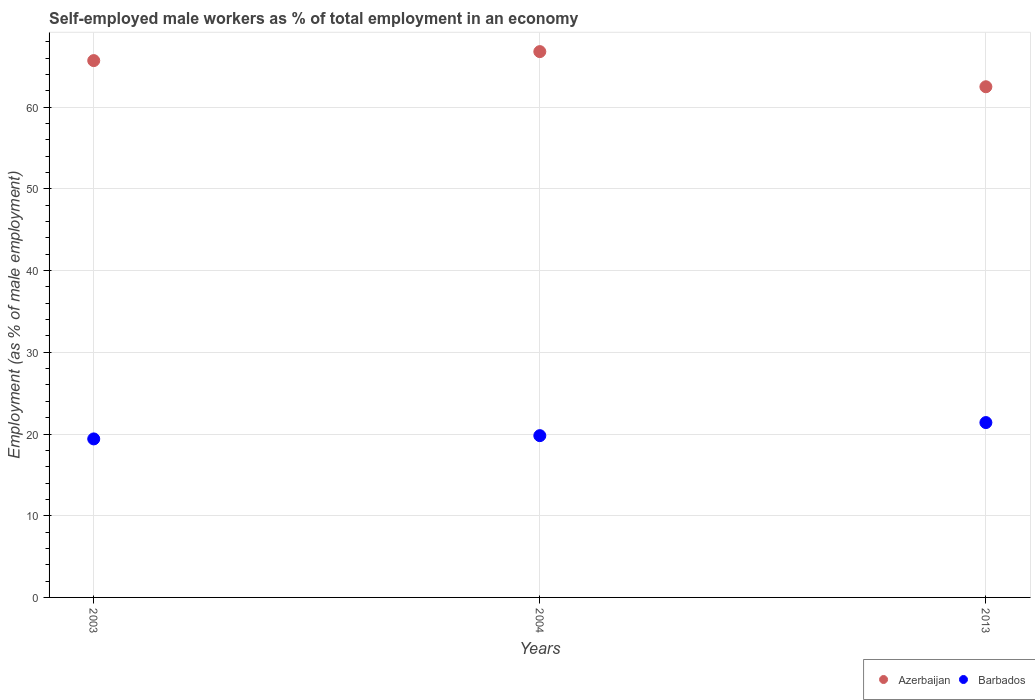Is the number of dotlines equal to the number of legend labels?
Your response must be concise. Yes. What is the percentage of self-employed male workers in Barbados in 2003?
Make the answer very short. 19.4. Across all years, what is the maximum percentage of self-employed male workers in Barbados?
Offer a terse response. 21.4. Across all years, what is the minimum percentage of self-employed male workers in Barbados?
Your answer should be very brief. 19.4. What is the total percentage of self-employed male workers in Azerbaijan in the graph?
Offer a terse response. 195. What is the difference between the percentage of self-employed male workers in Azerbaijan in 2004 and that in 2013?
Make the answer very short. 4.3. What is the difference between the percentage of self-employed male workers in Barbados in 2004 and the percentage of self-employed male workers in Azerbaijan in 2013?
Ensure brevity in your answer.  -42.7. What is the average percentage of self-employed male workers in Barbados per year?
Give a very brief answer. 20.2. In the year 2013, what is the difference between the percentage of self-employed male workers in Azerbaijan and percentage of self-employed male workers in Barbados?
Provide a succinct answer. 41.1. In how many years, is the percentage of self-employed male workers in Barbados greater than 58 %?
Make the answer very short. 0. What is the ratio of the percentage of self-employed male workers in Barbados in 2003 to that in 2013?
Your answer should be very brief. 0.91. Is the difference between the percentage of self-employed male workers in Azerbaijan in 2004 and 2013 greater than the difference between the percentage of self-employed male workers in Barbados in 2004 and 2013?
Provide a short and direct response. Yes. What is the difference between the highest and the second highest percentage of self-employed male workers in Barbados?
Offer a terse response. 1.6. What is the difference between the highest and the lowest percentage of self-employed male workers in Azerbaijan?
Make the answer very short. 4.3. Is the sum of the percentage of self-employed male workers in Azerbaijan in 2004 and 2013 greater than the maximum percentage of self-employed male workers in Barbados across all years?
Provide a succinct answer. Yes. How many years are there in the graph?
Offer a very short reply. 3. Does the graph contain any zero values?
Give a very brief answer. No. Does the graph contain grids?
Provide a short and direct response. Yes. Where does the legend appear in the graph?
Ensure brevity in your answer.  Bottom right. How many legend labels are there?
Ensure brevity in your answer.  2. What is the title of the graph?
Ensure brevity in your answer.  Self-employed male workers as % of total employment in an economy. Does "Low & middle income" appear as one of the legend labels in the graph?
Your answer should be very brief. No. What is the label or title of the X-axis?
Ensure brevity in your answer.  Years. What is the label or title of the Y-axis?
Give a very brief answer. Employment (as % of male employment). What is the Employment (as % of male employment) of Azerbaijan in 2003?
Keep it short and to the point. 65.7. What is the Employment (as % of male employment) in Barbados in 2003?
Offer a terse response. 19.4. What is the Employment (as % of male employment) of Azerbaijan in 2004?
Give a very brief answer. 66.8. What is the Employment (as % of male employment) in Barbados in 2004?
Provide a succinct answer. 19.8. What is the Employment (as % of male employment) of Azerbaijan in 2013?
Your response must be concise. 62.5. What is the Employment (as % of male employment) of Barbados in 2013?
Offer a terse response. 21.4. Across all years, what is the maximum Employment (as % of male employment) in Azerbaijan?
Ensure brevity in your answer.  66.8. Across all years, what is the maximum Employment (as % of male employment) in Barbados?
Your answer should be very brief. 21.4. Across all years, what is the minimum Employment (as % of male employment) in Azerbaijan?
Your answer should be compact. 62.5. Across all years, what is the minimum Employment (as % of male employment) of Barbados?
Provide a succinct answer. 19.4. What is the total Employment (as % of male employment) in Azerbaijan in the graph?
Offer a very short reply. 195. What is the total Employment (as % of male employment) in Barbados in the graph?
Give a very brief answer. 60.6. What is the difference between the Employment (as % of male employment) of Azerbaijan in 2004 and that in 2013?
Keep it short and to the point. 4.3. What is the difference between the Employment (as % of male employment) in Azerbaijan in 2003 and the Employment (as % of male employment) in Barbados in 2004?
Your answer should be very brief. 45.9. What is the difference between the Employment (as % of male employment) of Azerbaijan in 2003 and the Employment (as % of male employment) of Barbados in 2013?
Keep it short and to the point. 44.3. What is the difference between the Employment (as % of male employment) of Azerbaijan in 2004 and the Employment (as % of male employment) of Barbados in 2013?
Make the answer very short. 45.4. What is the average Employment (as % of male employment) in Barbados per year?
Make the answer very short. 20.2. In the year 2003, what is the difference between the Employment (as % of male employment) in Azerbaijan and Employment (as % of male employment) in Barbados?
Keep it short and to the point. 46.3. In the year 2013, what is the difference between the Employment (as % of male employment) in Azerbaijan and Employment (as % of male employment) in Barbados?
Provide a short and direct response. 41.1. What is the ratio of the Employment (as % of male employment) in Azerbaijan in 2003 to that in 2004?
Provide a succinct answer. 0.98. What is the ratio of the Employment (as % of male employment) in Barbados in 2003 to that in 2004?
Your answer should be compact. 0.98. What is the ratio of the Employment (as % of male employment) in Azerbaijan in 2003 to that in 2013?
Provide a succinct answer. 1.05. What is the ratio of the Employment (as % of male employment) of Barbados in 2003 to that in 2013?
Your response must be concise. 0.91. What is the ratio of the Employment (as % of male employment) in Azerbaijan in 2004 to that in 2013?
Ensure brevity in your answer.  1.07. What is the ratio of the Employment (as % of male employment) of Barbados in 2004 to that in 2013?
Your response must be concise. 0.93. What is the difference between the highest and the lowest Employment (as % of male employment) in Azerbaijan?
Offer a terse response. 4.3. 